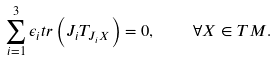<formula> <loc_0><loc_0><loc_500><loc_500>\sum _ { i = 1 } ^ { 3 } \epsilon _ { i } t r \left ( J _ { i } T _ { J _ { i } X } \right ) = 0 , \quad \forall X \in T M .</formula> 